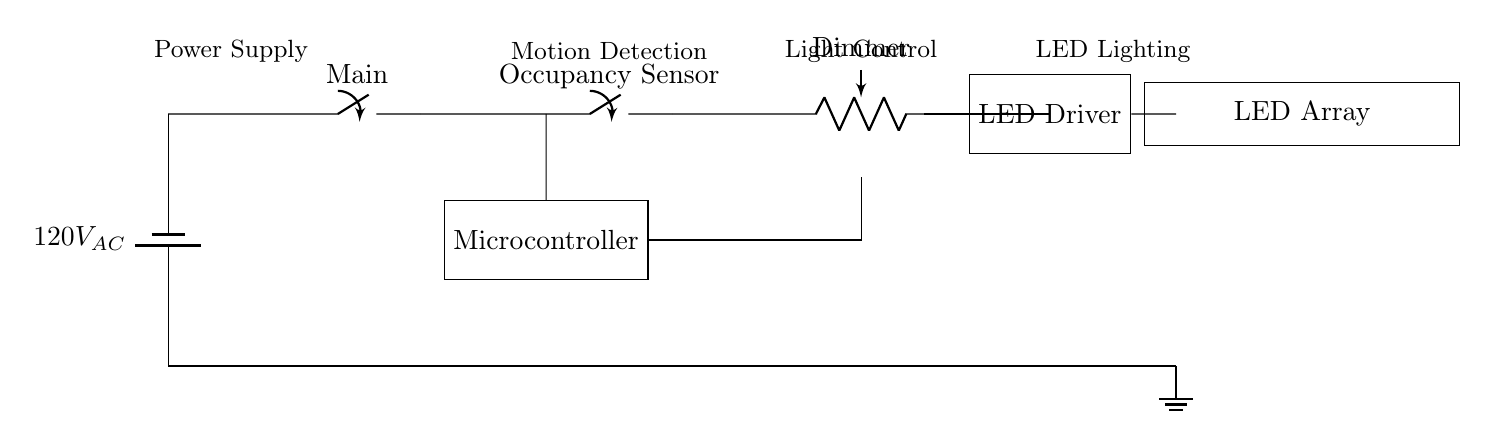What is the power supply voltage for this circuit? The power supply voltage is indicated next to the battery symbol in the circuit diagram. It shows a value of 120V AC.
Answer: 120V AC What component is responsible for detecting occupancy? The circuit diagram labels a specific switch as the occupancy sensor. This component is situated after the main switch and before the dimming control, highlighting its function to sense occupancy.
Answer: Occupancy Sensor What adjustment capability does this circuit have? The circuit diagram includes a potentiometer labeled as "Dimmer." This indicates the circuit has the capability to adjust the level of lighting, allowing brightness to be dimmed or brightened.
Answer: Dimming How many LED arrays are depicted in the circuit? The circuit diagram shows three LED symbols stacked vertically, indicating that there are three LED light sources as part of the LED array. The rectangle surrounding them represents the complete LED array structure.
Answer: Three What role does the microcontroller play in this circuit? The microcontroller is linked to both the occupancy sensor and the dimmer. It processes data from the occupancy sensor to control the dimming functionality of the lighting, ensuring efficient operation based on presence and brightness settings.
Answer: Light Control What is the purpose of the LED driver in this circuit? The LED driver in the circuit diagram is identified as the component that provides the necessary current and voltage regulation to drive the LED arrays properly, thus converting high voltage from the power supply into usable forms for the LEDs.
Answer: LED Driver 